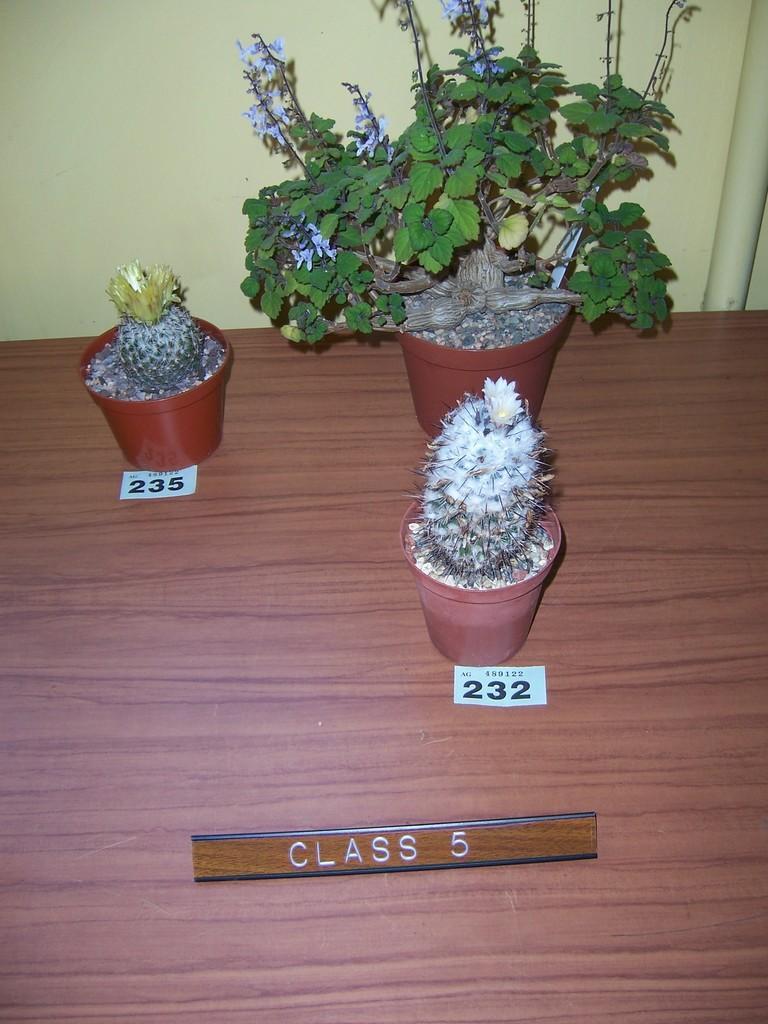Describe this image in one or two sentences. In this picture I can see plants in the pots, there are papers and a name plate on the table, and in the background there is a wall. 